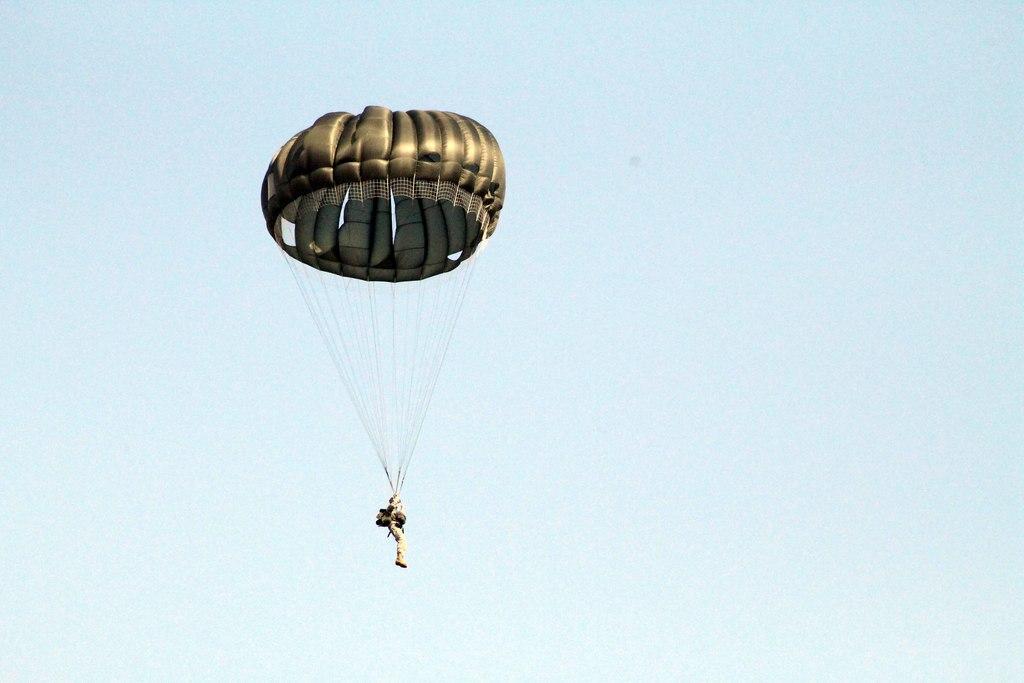Please provide a concise description of this image. In this picture we can see a parachute flying in the air and in the background we can see the sky. 